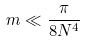<formula> <loc_0><loc_0><loc_500><loc_500>m \ll \frac { \pi } { 8 N ^ { 4 } }</formula> 